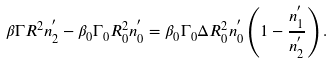Convert formula to latex. <formula><loc_0><loc_0><loc_500><loc_500>\beta \Gamma R ^ { 2 } n _ { 2 } ^ { ^ { \prime } } - \beta _ { 0 } \Gamma _ { 0 } R _ { 0 } ^ { 2 } n _ { 0 } ^ { ^ { \prime } } = \beta _ { 0 } \Gamma _ { 0 } \Delta R _ { 0 } ^ { 2 } n _ { 0 } ^ { ^ { \prime } } \left ( 1 - \frac { n _ { 1 } ^ { ^ { \prime } } } { n _ { 2 } ^ { ^ { \prime } } } \right ) .</formula> 